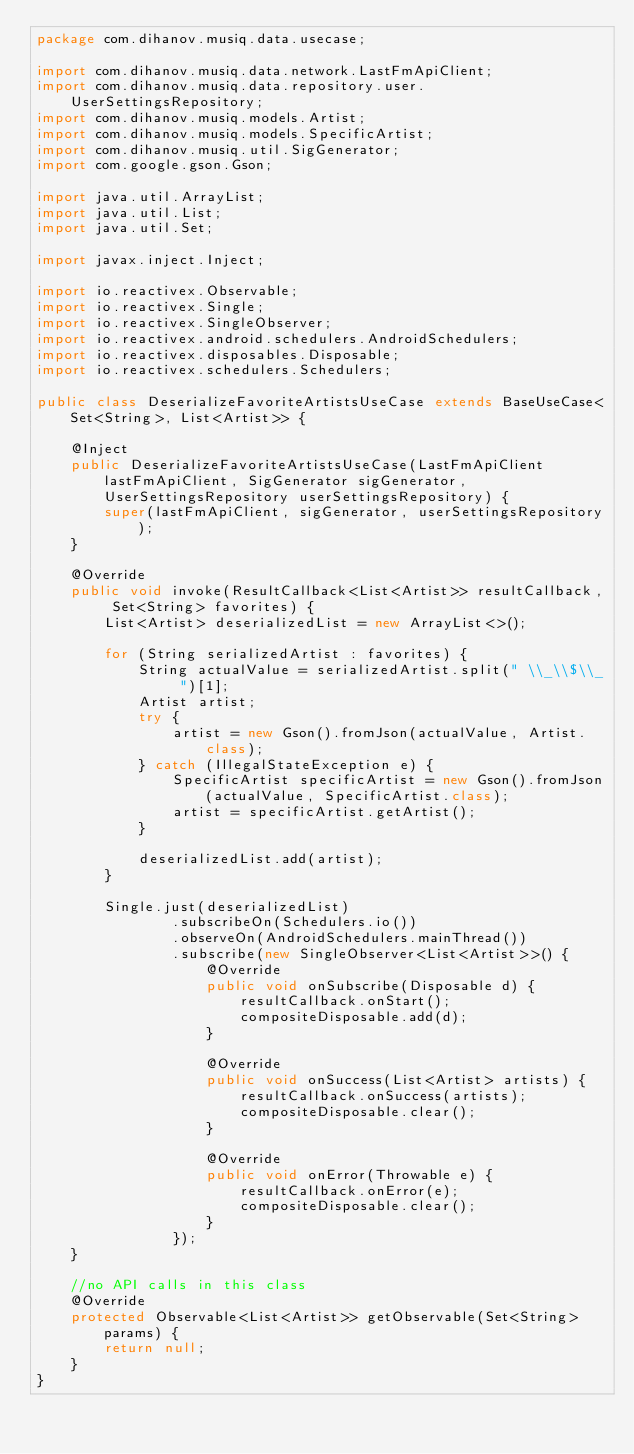Convert code to text. <code><loc_0><loc_0><loc_500><loc_500><_Java_>package com.dihanov.musiq.data.usecase;

import com.dihanov.musiq.data.network.LastFmApiClient;
import com.dihanov.musiq.data.repository.user.UserSettingsRepository;
import com.dihanov.musiq.models.Artist;
import com.dihanov.musiq.models.SpecificArtist;
import com.dihanov.musiq.util.SigGenerator;
import com.google.gson.Gson;

import java.util.ArrayList;
import java.util.List;
import java.util.Set;

import javax.inject.Inject;

import io.reactivex.Observable;
import io.reactivex.Single;
import io.reactivex.SingleObserver;
import io.reactivex.android.schedulers.AndroidSchedulers;
import io.reactivex.disposables.Disposable;
import io.reactivex.schedulers.Schedulers;

public class DeserializeFavoriteArtistsUseCase extends BaseUseCase<Set<String>, List<Artist>> {

    @Inject
    public DeserializeFavoriteArtistsUseCase(LastFmApiClient lastFmApiClient, SigGenerator sigGenerator, UserSettingsRepository userSettingsRepository) {
        super(lastFmApiClient, sigGenerator, userSettingsRepository);
    }

    @Override
    public void invoke(ResultCallback<List<Artist>> resultCallback, Set<String> favorites) {
        List<Artist> deserializedList = new ArrayList<>();

        for (String serializedArtist : favorites) {
            String actualValue = serializedArtist.split(" \\_\\$\\_ ")[1];
            Artist artist;
            try {
                artist = new Gson().fromJson(actualValue, Artist.class);
            } catch (IllegalStateException e) {
                SpecificArtist specificArtist = new Gson().fromJson(actualValue, SpecificArtist.class);
                artist = specificArtist.getArtist();
            }

            deserializedList.add(artist);
        }

        Single.just(deserializedList)
                .subscribeOn(Schedulers.io())
                .observeOn(AndroidSchedulers.mainThread())
                .subscribe(new SingleObserver<List<Artist>>() {
                    @Override
                    public void onSubscribe(Disposable d) {
                        resultCallback.onStart();
                        compositeDisposable.add(d);
                    }

                    @Override
                    public void onSuccess(List<Artist> artists) {
                        resultCallback.onSuccess(artists);
                        compositeDisposable.clear();
                    }

                    @Override
                    public void onError(Throwable e) {
                        resultCallback.onError(e);
                        compositeDisposable.clear();
                    }
                });
    }

    //no API calls in this class
    @Override
    protected Observable<List<Artist>> getObservable(Set<String> params) {
        return null;
    }
}
</code> 